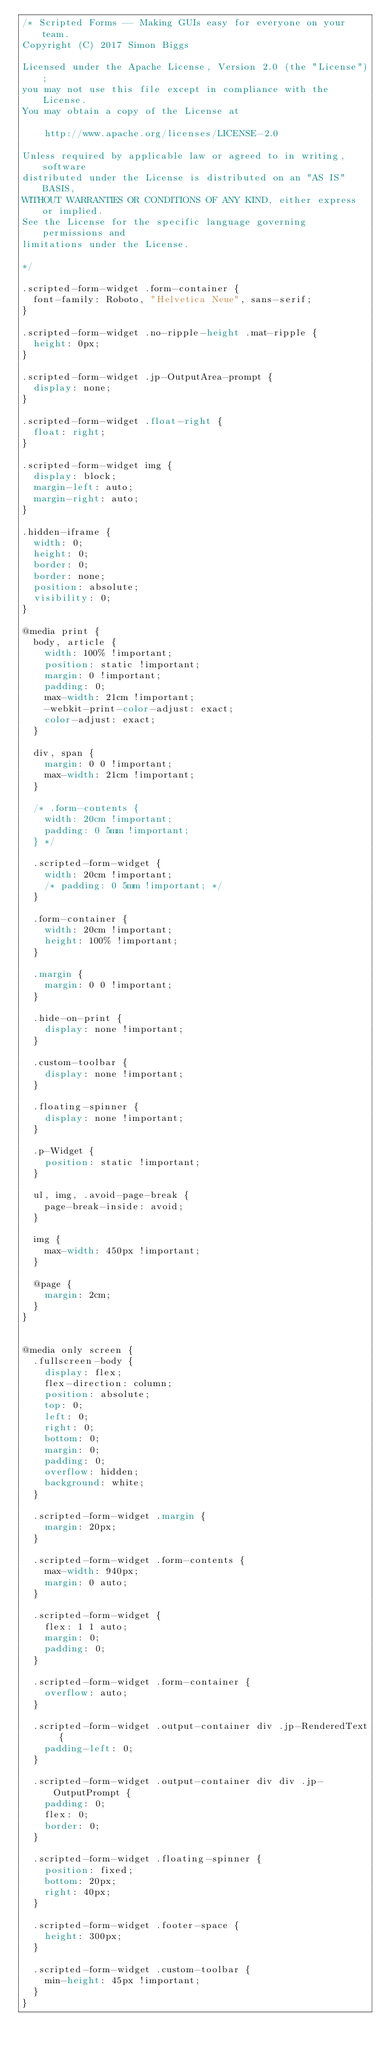<code> <loc_0><loc_0><loc_500><loc_500><_CSS_>/* Scripted Forms -- Making GUIs easy for everyone on your team.
Copyright (C) 2017 Simon Biggs

Licensed under the Apache License, Version 2.0 (the "License");
you may not use this file except in compliance with the License.
You may obtain a copy of the License at

    http://www.apache.org/licenses/LICENSE-2.0

Unless required by applicable law or agreed to in writing, software
distributed under the License is distributed on an "AS IS" BASIS,
WITHOUT WARRANTIES OR CONDITIONS OF ANY KIND, either express or implied.
See the License for the specific language governing permissions and
limitations under the License.

*/

.scripted-form-widget .form-container {
  font-family: Roboto, "Helvetica Neue", sans-serif;
}

.scripted-form-widget .no-ripple-height .mat-ripple {
  height: 0px;
}

.scripted-form-widget .jp-OutputArea-prompt {
  display: none;
}

.scripted-form-widget .float-right {
  float: right;
}

.scripted-form-widget img {
  display: block;
  margin-left: auto;
  margin-right: auto;
}

.hidden-iframe {
  width: 0;
  height: 0;
  border: 0;
  border: none;
  position: absolute;
  visibility: 0;
}

@media print {
  body, article {
    width: 100% !important;
    position: static !important;
    margin: 0 !important;
    padding: 0;
    max-width: 21cm !important;
    -webkit-print-color-adjust: exact;
    color-adjust: exact;
  }

  div, span {
    margin: 0 0 !important;
    max-width: 21cm !important;
  }

  /* .form-contents {
    width: 20cm !important;
    padding: 0 5mm !important;
  } */

  .scripted-form-widget {
    width: 20cm !important;
    /* padding: 0 5mm !important; */
  }

  .form-container {
    width: 20cm !important;
    height: 100% !important;
  }

  .margin {
    margin: 0 0 !important;
  }

  .hide-on-print {
    display: none !important;
  }

  .custom-toolbar {
    display: none !important;
  }

  .floating-spinner {
    display: none !important;
  }

  .p-Widget {
    position: static !important;
  }

  ul, img, .avoid-page-break {
    page-break-inside: avoid;
  }

  img {
    max-width: 450px !important;
  }

  @page {
    margin: 2cm;
  }
}


@media only screen {
  .fullscreen-body {
    display: flex;
    flex-direction: column;
    position: absolute;
    top: 0;
    left: 0;
    right: 0;
    bottom: 0;
    margin: 0;
    padding: 0;
    overflow: hidden;
    background: white;
  }

  .scripted-form-widget .margin {
    margin: 20px;
  }

  .scripted-form-widget .form-contents {
    max-width: 940px;
    margin: 0 auto;
  }

  .scripted-form-widget {
    flex: 1 1 auto;
    margin: 0;
    padding: 0;
  }

  .scripted-form-widget .form-container {
    overflow: auto;
  }

  .scripted-form-widget .output-container div .jp-RenderedText {
    padding-left: 0;
  }

  .scripted-form-widget .output-container div div .jp-OutputPrompt {
    padding: 0;
    flex: 0;
    border: 0;
  }

  .scripted-form-widget .floating-spinner {
    position: fixed;
    bottom: 20px;
    right: 40px;
  }

  .scripted-form-widget .footer-space {
    height: 300px;
  }

  .scripted-form-widget .custom-toolbar {
    min-height: 45px !important;
  }
}</code> 